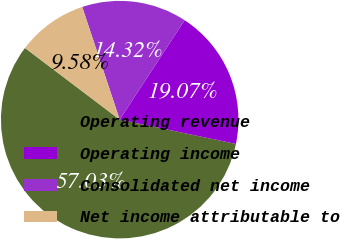<chart> <loc_0><loc_0><loc_500><loc_500><pie_chart><fcel>Operating revenue<fcel>Operating income<fcel>Consolidated net income<fcel>Net income attributable to<nl><fcel>57.03%<fcel>19.07%<fcel>14.32%<fcel>9.58%<nl></chart> 